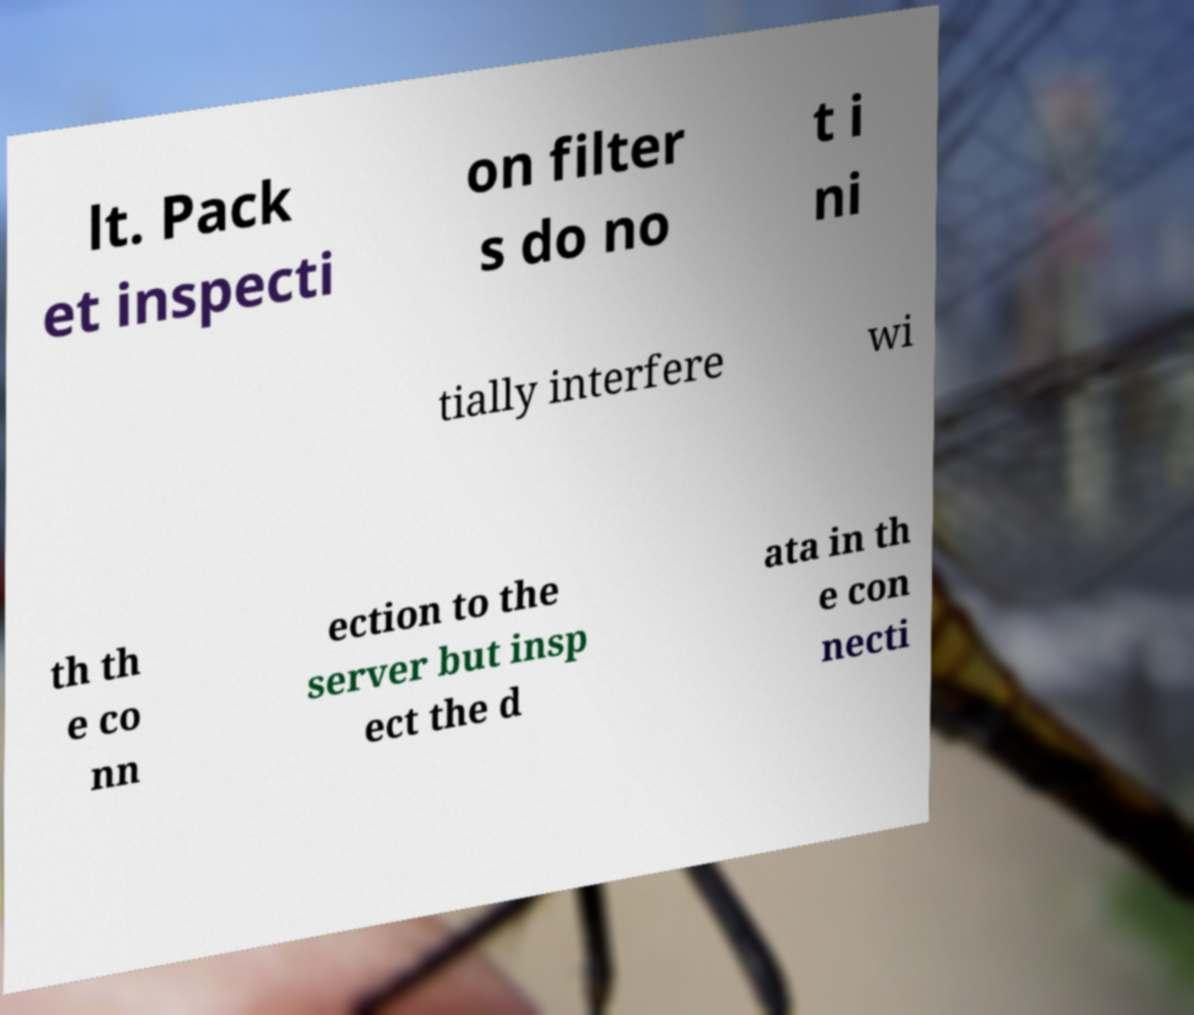For documentation purposes, I need the text within this image transcribed. Could you provide that? lt. Pack et inspecti on filter s do no t i ni tially interfere wi th th e co nn ection to the server but insp ect the d ata in th e con necti 